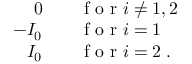Convert formula to latex. <formula><loc_0><loc_0><loc_500><loc_500>\begin{array} { r l } { 0 \quad } & f o r i \neq 1 , 2 } \\ { - I _ { 0 } \quad } & f o r i = 1 } \\ { I _ { 0 } \quad } & f o r i = 2 \, . } \end{array}</formula> 